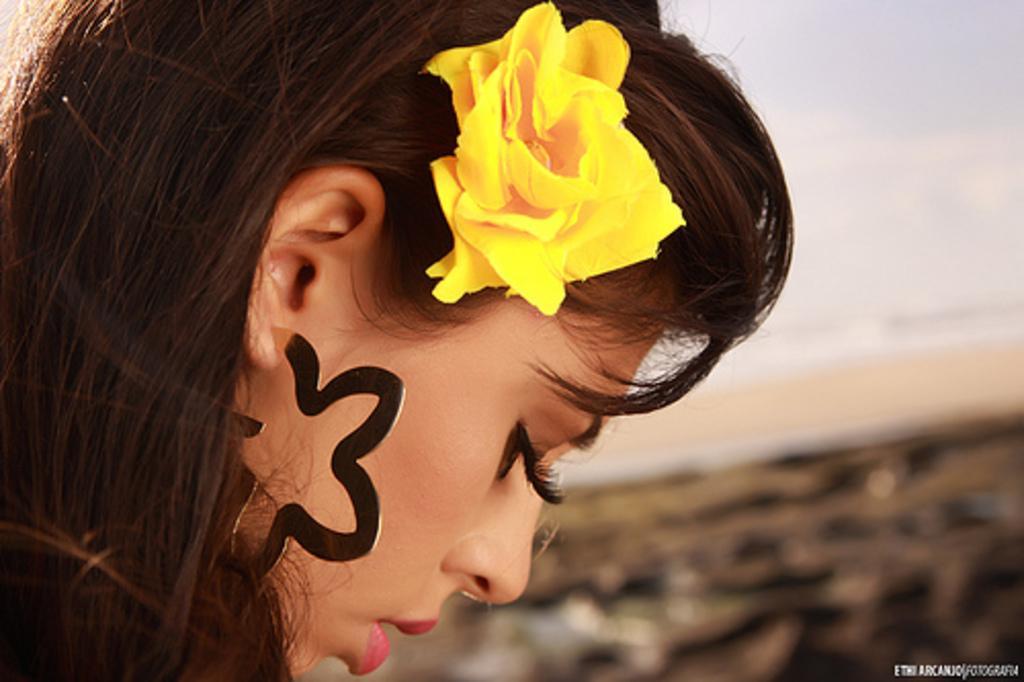Describe this image in one or two sentences. In this picture there is a girl with close view in the image wearing a yellow color flower in the hair. Behind there is a blur background. 